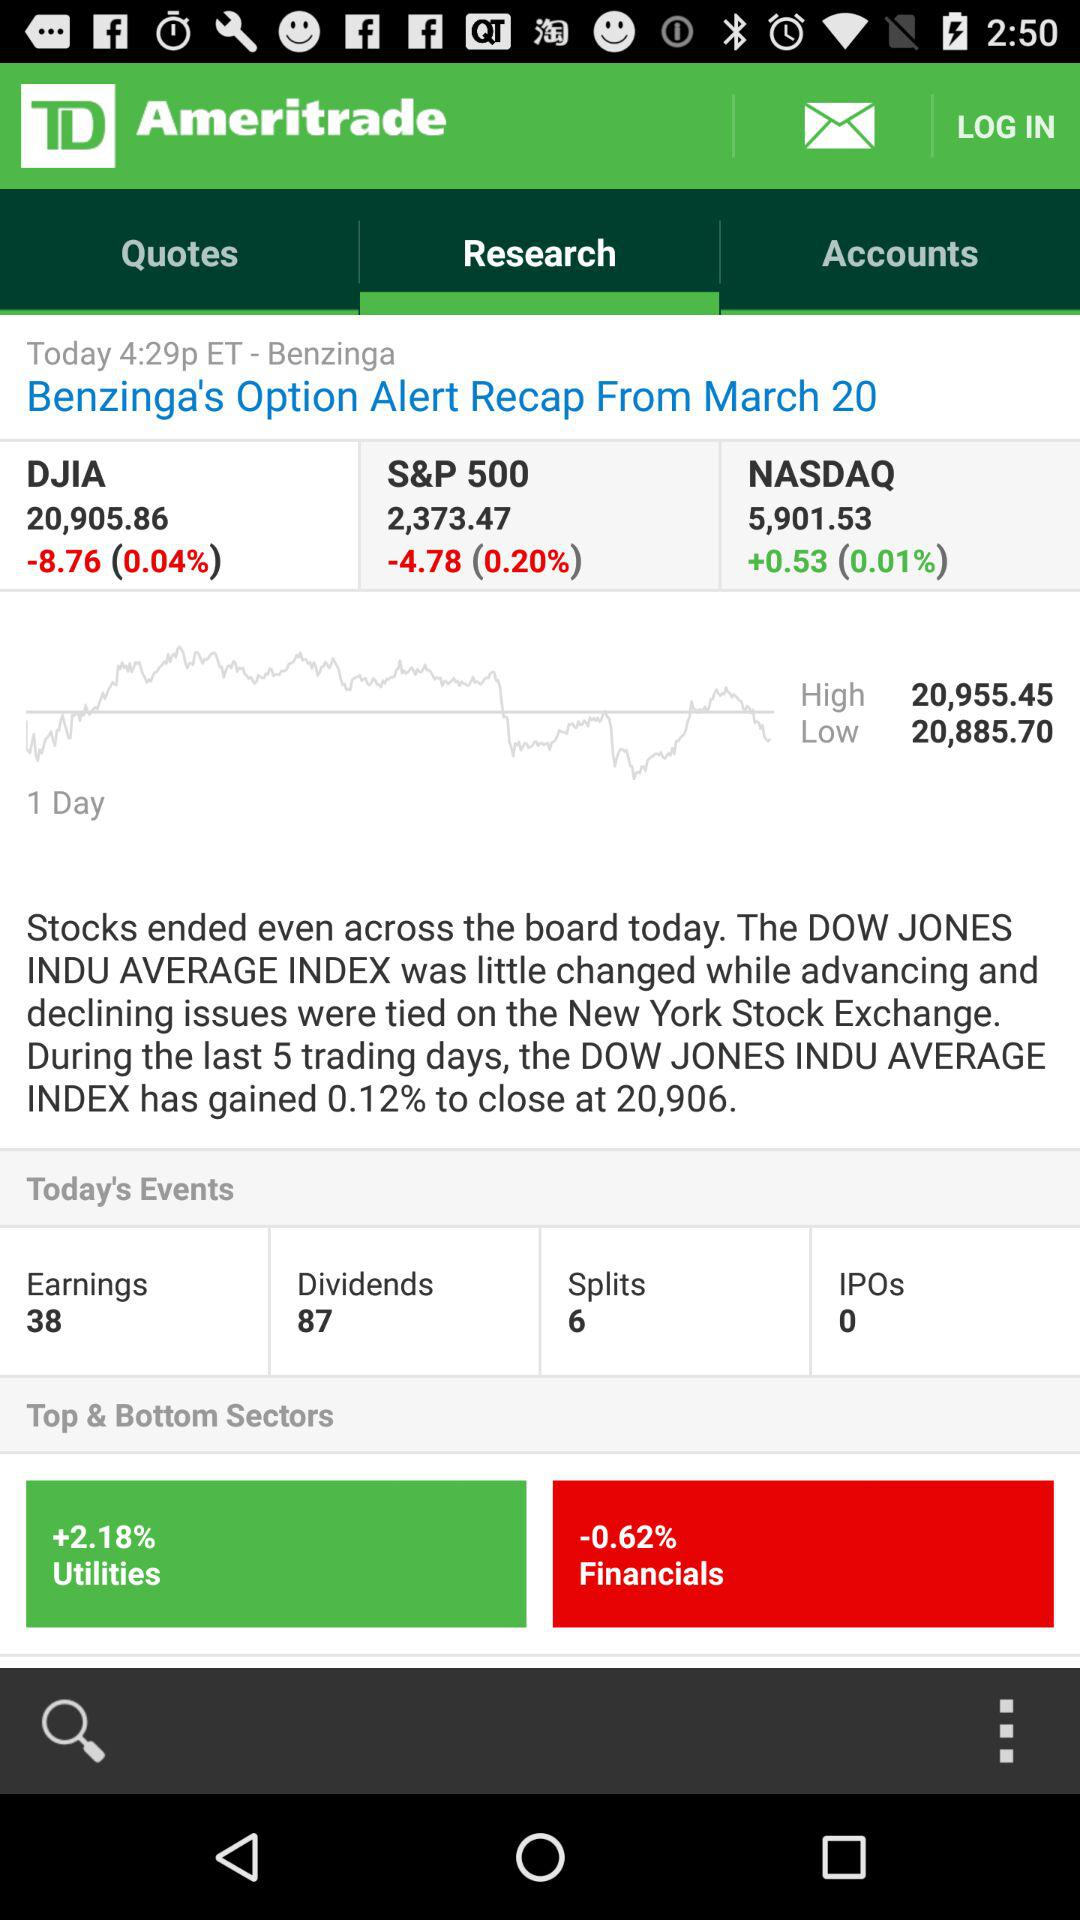Which option is selected for Ameritrade? The selected option is "Reaserch". 